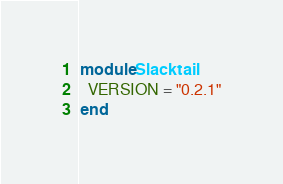Convert code to text. <code><loc_0><loc_0><loc_500><loc_500><_Ruby_>module Slacktail
  VERSION = "0.2.1"
end</code> 